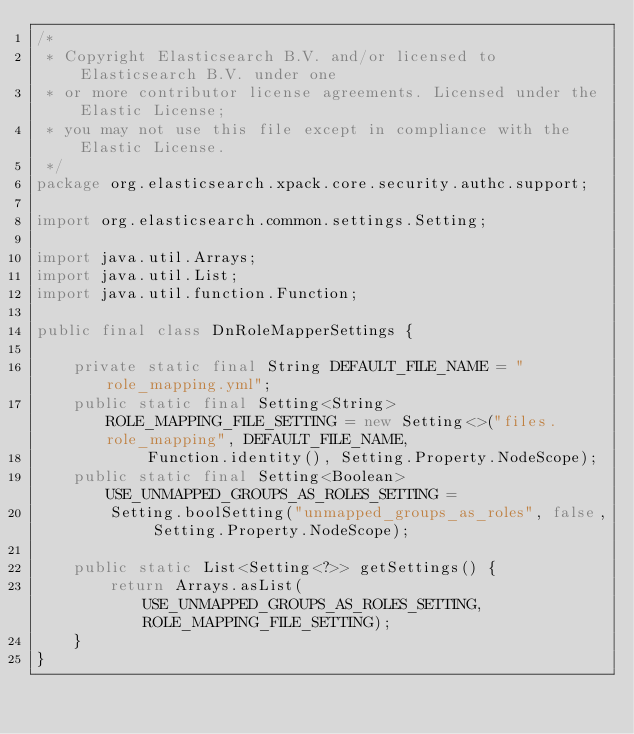<code> <loc_0><loc_0><loc_500><loc_500><_Java_>/*
 * Copyright Elasticsearch B.V. and/or licensed to Elasticsearch B.V. under one
 * or more contributor license agreements. Licensed under the Elastic License;
 * you may not use this file except in compliance with the Elastic License.
 */
package org.elasticsearch.xpack.core.security.authc.support;

import org.elasticsearch.common.settings.Setting;

import java.util.Arrays;
import java.util.List;
import java.util.function.Function;

public final class DnRoleMapperSettings {

    private static final String DEFAULT_FILE_NAME = "role_mapping.yml";
    public static final Setting<String> ROLE_MAPPING_FILE_SETTING = new Setting<>("files.role_mapping", DEFAULT_FILE_NAME,
            Function.identity(), Setting.Property.NodeScope);
    public static final Setting<Boolean> USE_UNMAPPED_GROUPS_AS_ROLES_SETTING =
        Setting.boolSetting("unmapped_groups_as_roles", false, Setting.Property.NodeScope);

    public static List<Setting<?>> getSettings() {
        return Arrays.asList(USE_UNMAPPED_GROUPS_AS_ROLES_SETTING, ROLE_MAPPING_FILE_SETTING);
    }
}
</code> 